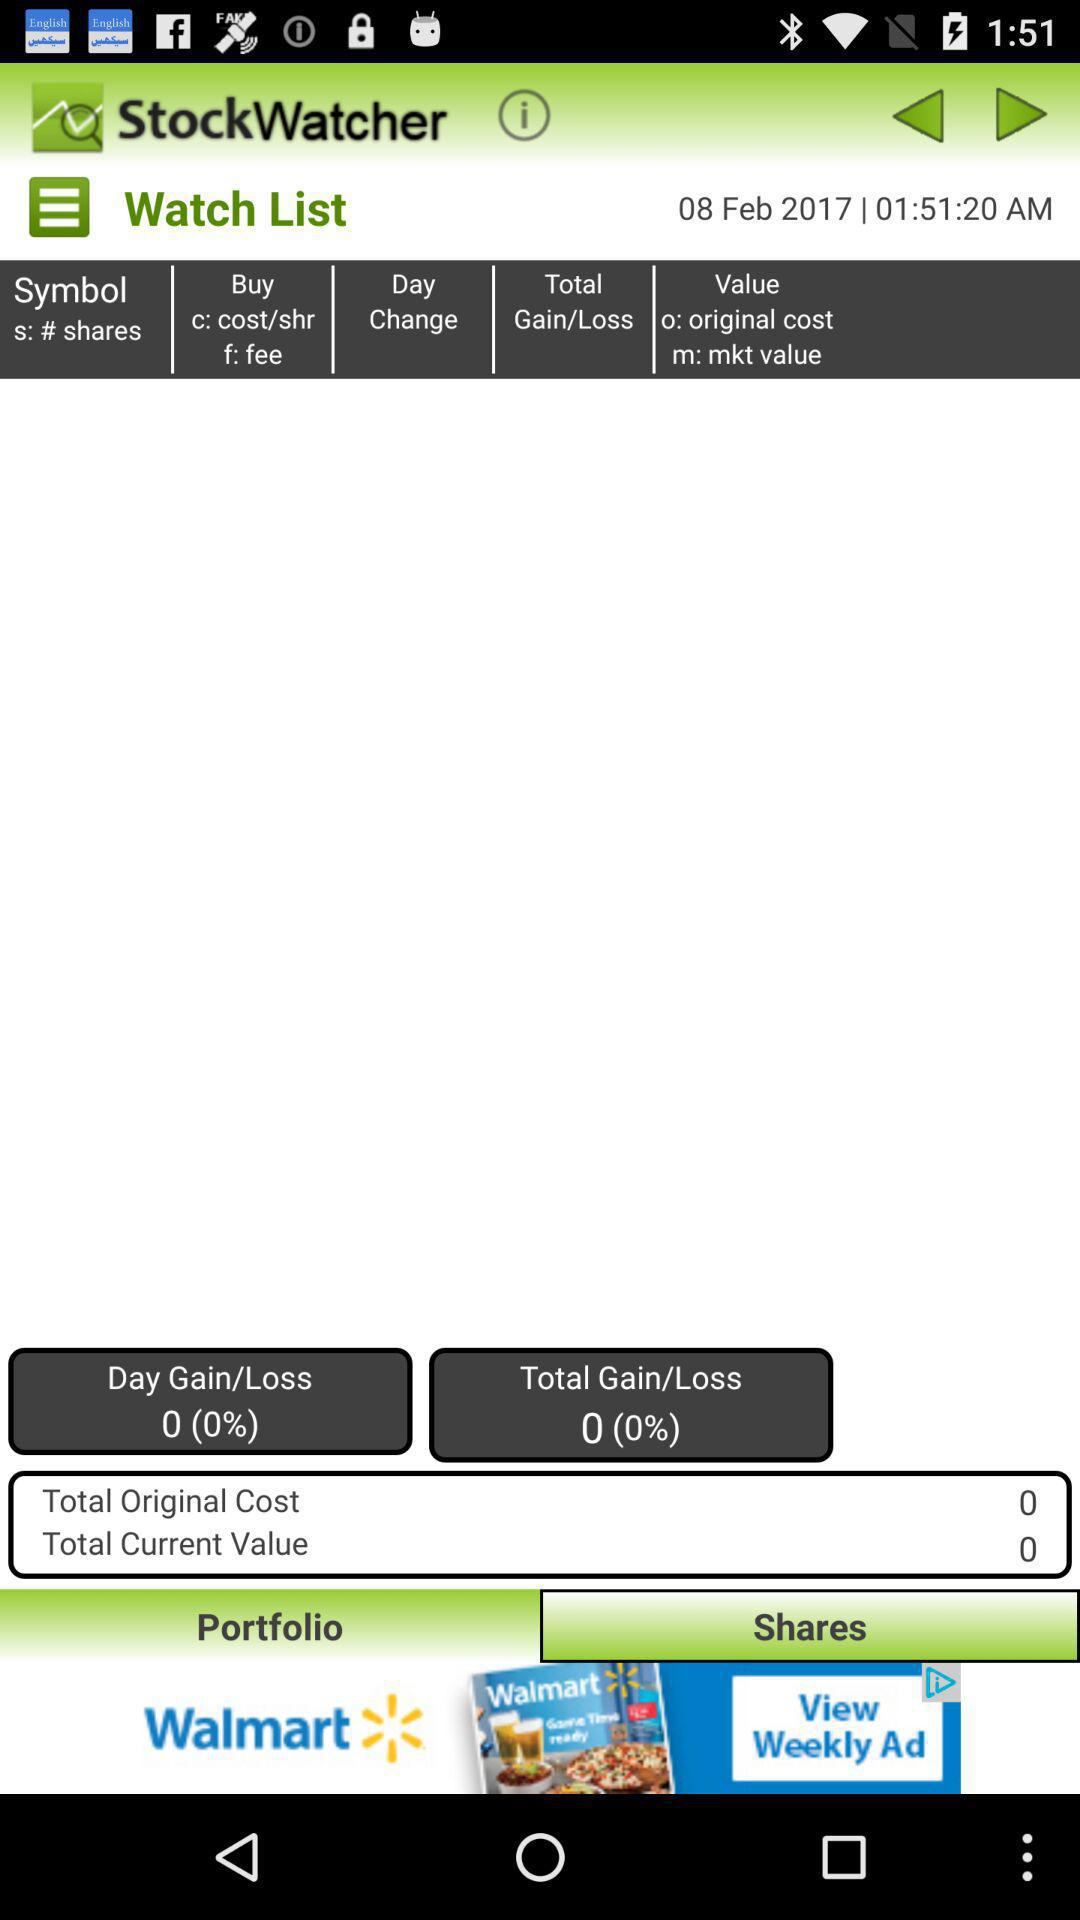What is the total original cost? The total original cost is 0. 